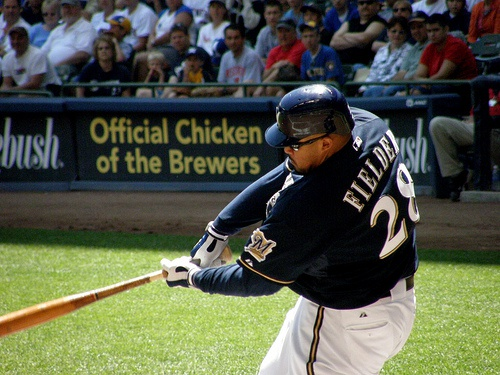Describe the objects in this image and their specific colors. I can see people in black, lightgray, and darkgray tones, people in black, gray, maroon, and darkgray tones, people in black and gray tones, people in black, maroon, and gray tones, and people in black, gray, and navy tones in this image. 